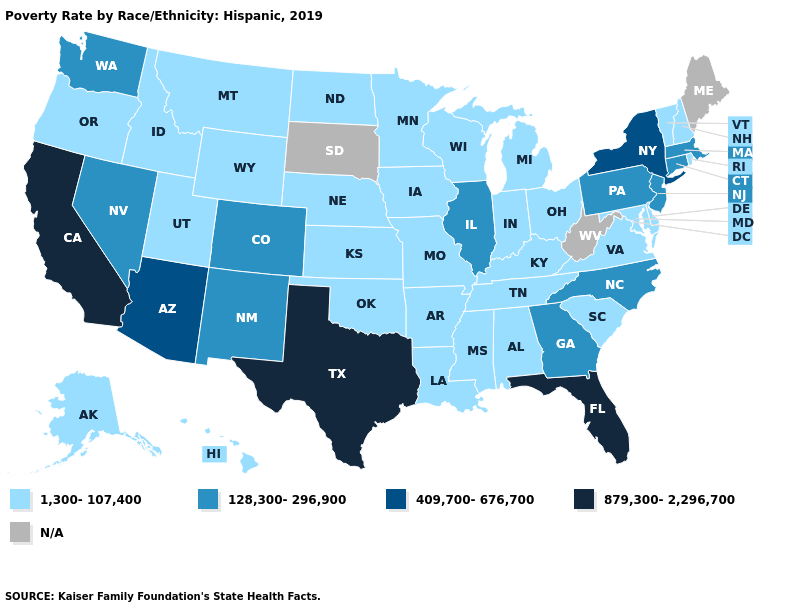Which states have the highest value in the USA?
Answer briefly. California, Florida, Texas. What is the value of Massachusetts?
Concise answer only. 128,300-296,900. Among the states that border Nevada , which have the lowest value?
Keep it brief. Idaho, Oregon, Utah. Does Iowa have the lowest value in the MidWest?
Quick response, please. Yes. Name the states that have a value in the range 879,300-2,296,700?
Answer briefly. California, Florida, Texas. Name the states that have a value in the range 409,700-676,700?
Write a very short answer. Arizona, New York. Name the states that have a value in the range 128,300-296,900?
Answer briefly. Colorado, Connecticut, Georgia, Illinois, Massachusetts, Nevada, New Jersey, New Mexico, North Carolina, Pennsylvania, Washington. Does Texas have the highest value in the South?
Write a very short answer. Yes. What is the value of Arkansas?
Give a very brief answer. 1,300-107,400. What is the value of Tennessee?
Keep it brief. 1,300-107,400. What is the value of Nebraska?
Keep it brief. 1,300-107,400. Which states have the highest value in the USA?
Write a very short answer. California, Florida, Texas. Which states have the lowest value in the MidWest?
Short answer required. Indiana, Iowa, Kansas, Michigan, Minnesota, Missouri, Nebraska, North Dakota, Ohio, Wisconsin. Name the states that have a value in the range 1,300-107,400?
Concise answer only. Alabama, Alaska, Arkansas, Delaware, Hawaii, Idaho, Indiana, Iowa, Kansas, Kentucky, Louisiana, Maryland, Michigan, Minnesota, Mississippi, Missouri, Montana, Nebraska, New Hampshire, North Dakota, Ohio, Oklahoma, Oregon, Rhode Island, South Carolina, Tennessee, Utah, Vermont, Virginia, Wisconsin, Wyoming. 